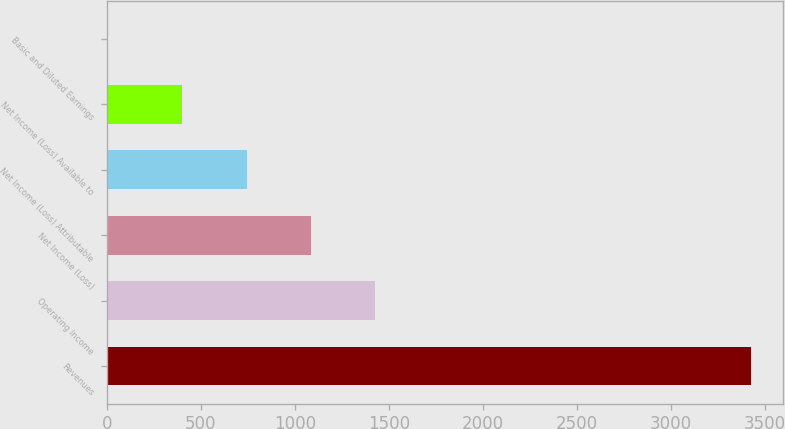Convert chart to OTSL. <chart><loc_0><loc_0><loc_500><loc_500><bar_chart><fcel>Revenues<fcel>Operating Income<fcel>Net Income (Loss)<fcel>Net Income (Loss) Attributable<fcel>Net Income (Loss) Available to<fcel>Basic and Diluted Earnings<nl><fcel>3424<fcel>1428.14<fcel>1085.76<fcel>743.38<fcel>401<fcel>0.18<nl></chart> 